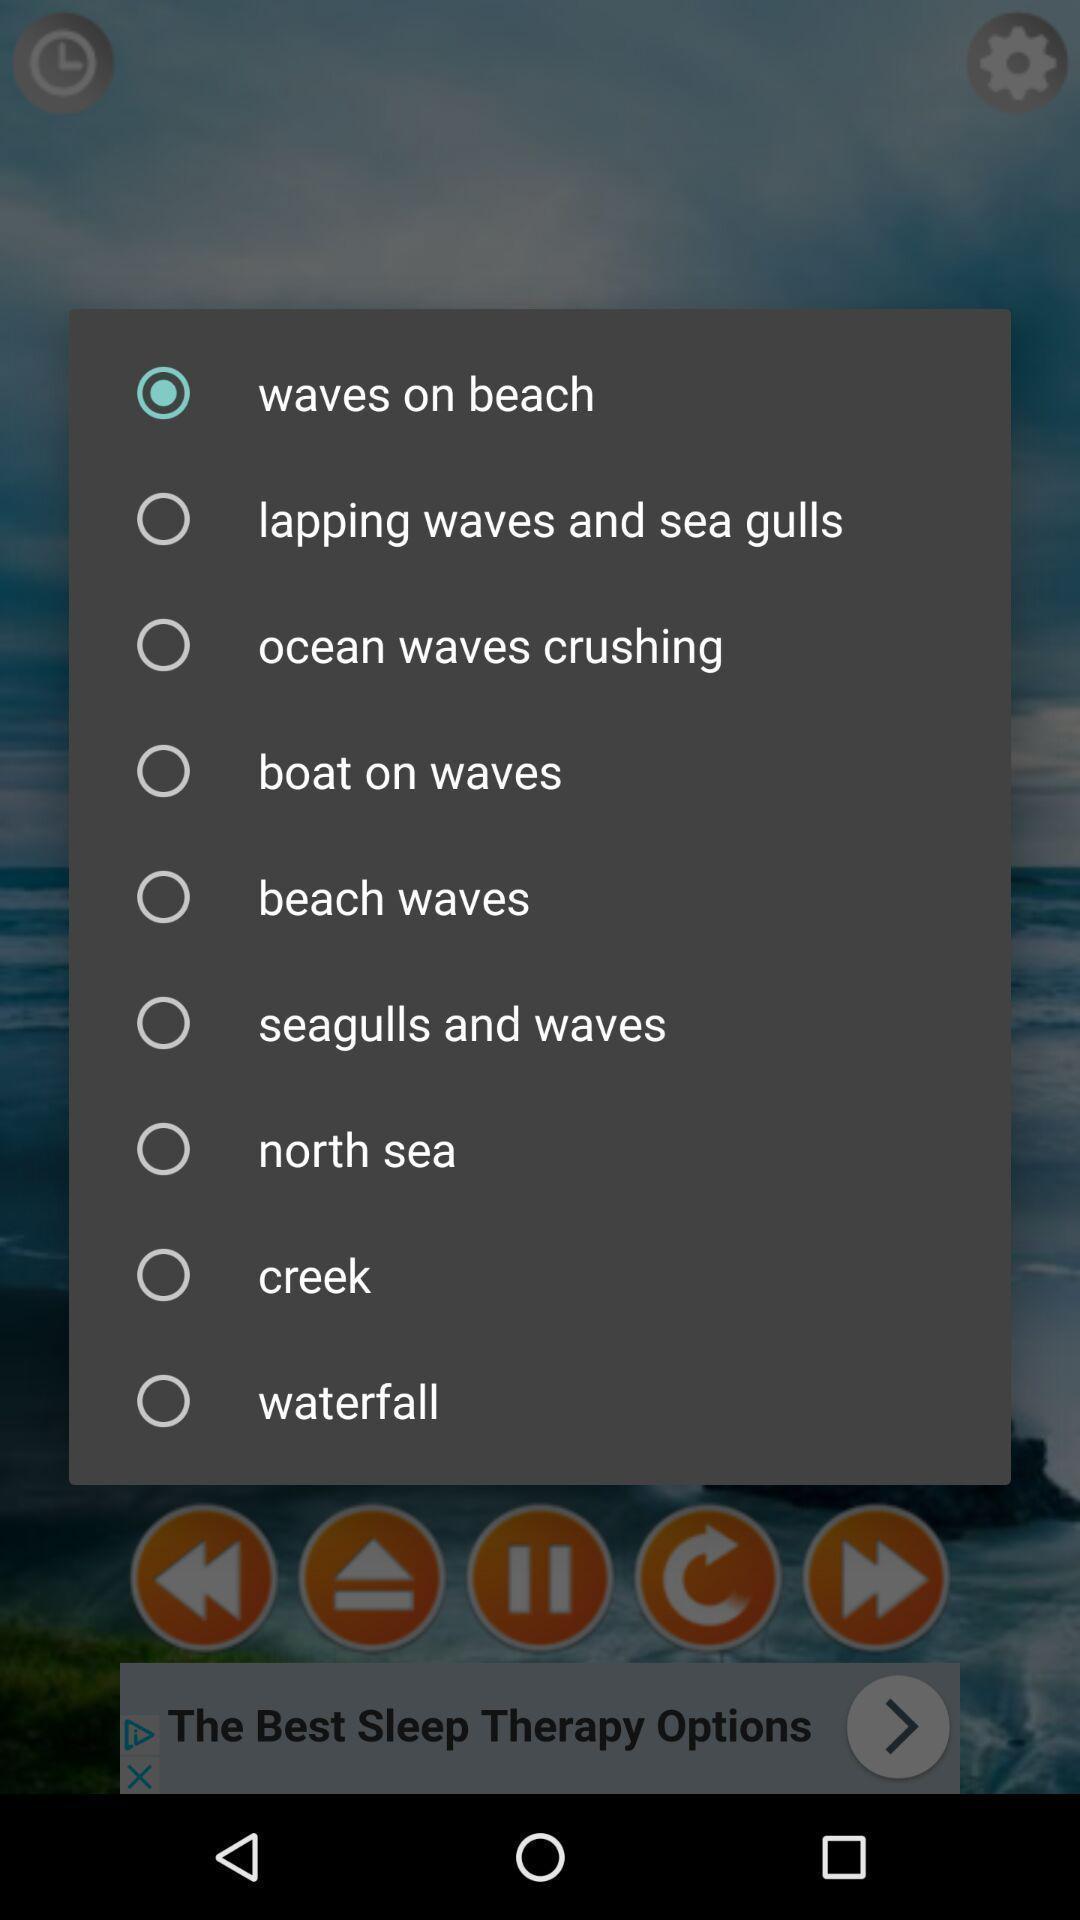Provide a description of this screenshot. Pop-up with list of different sounds. 